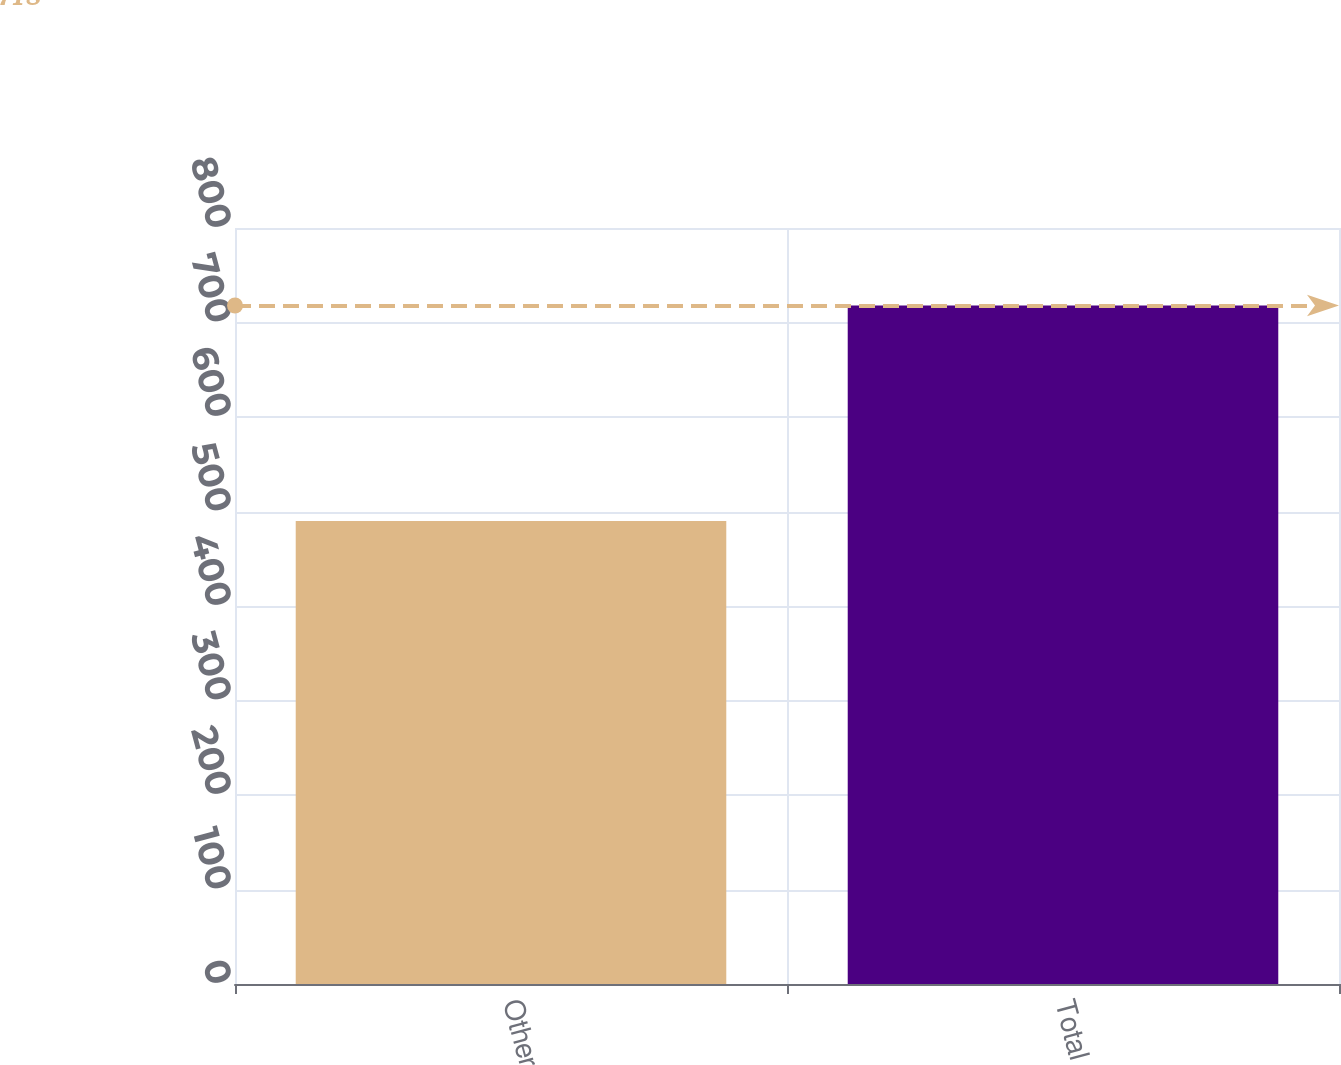Convert chart to OTSL. <chart><loc_0><loc_0><loc_500><loc_500><bar_chart><fcel>Other<fcel>Total<nl><fcel>490<fcel>718<nl></chart> 